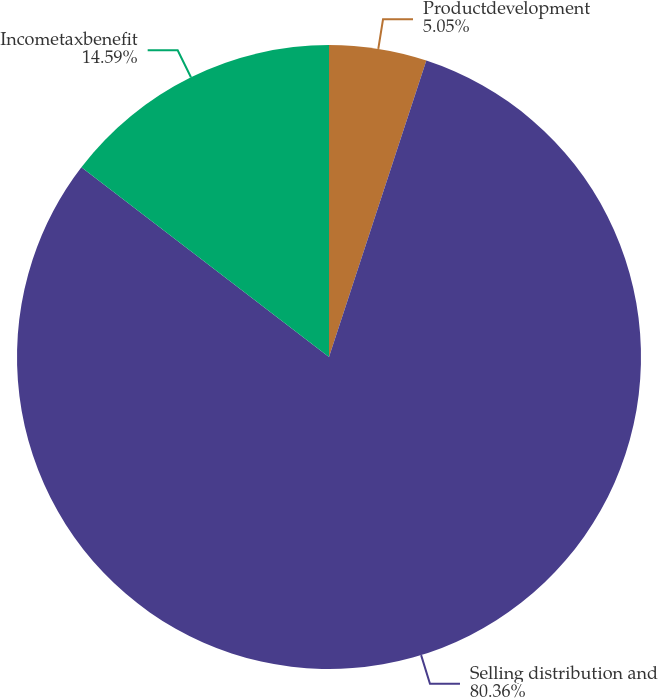<chart> <loc_0><loc_0><loc_500><loc_500><pie_chart><fcel>Productdevelopment<fcel>Selling distribution and<fcel>Incometaxbenefit<nl><fcel>5.05%<fcel>80.36%<fcel>14.59%<nl></chart> 